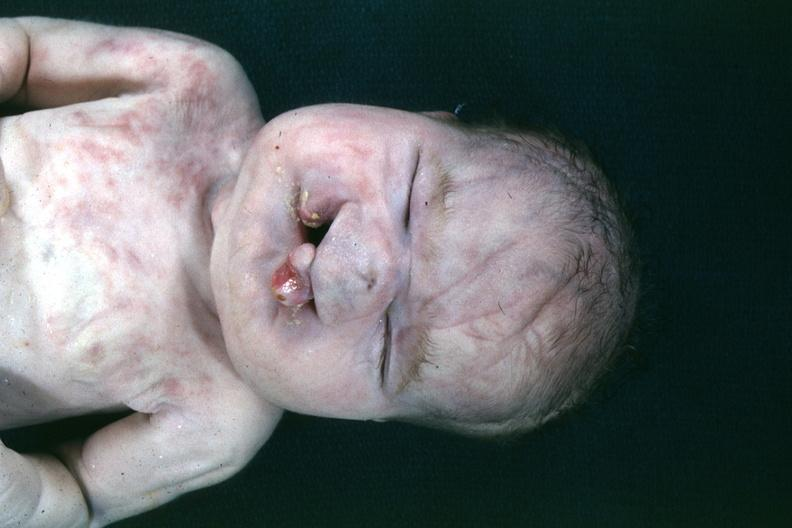s bilateral cleft palate present?
Answer the question using a single word or phrase. Yes 